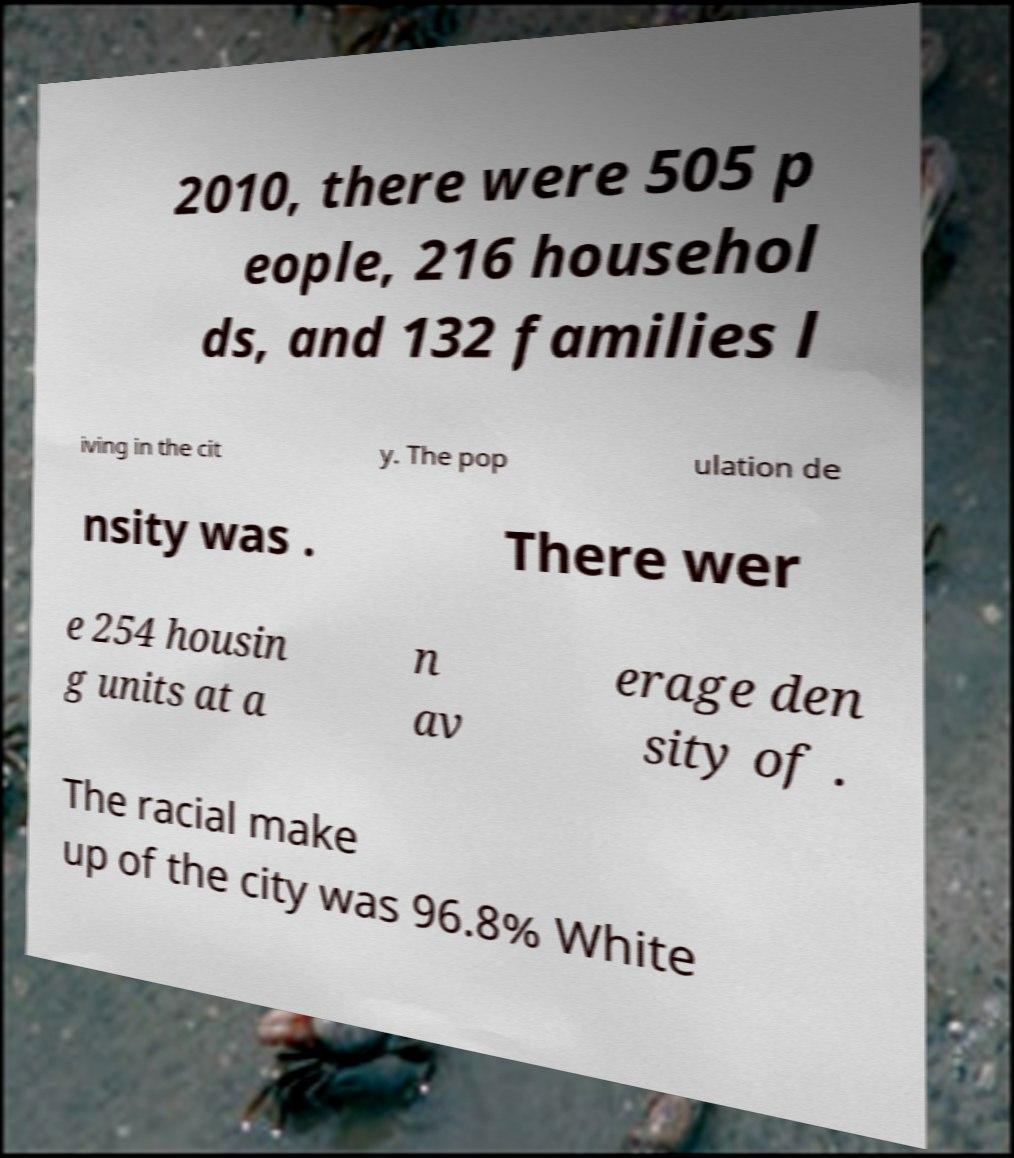There's text embedded in this image that I need extracted. Can you transcribe it verbatim? 2010, there were 505 p eople, 216 househol ds, and 132 families l iving in the cit y. The pop ulation de nsity was . There wer e 254 housin g units at a n av erage den sity of . The racial make up of the city was 96.8% White 